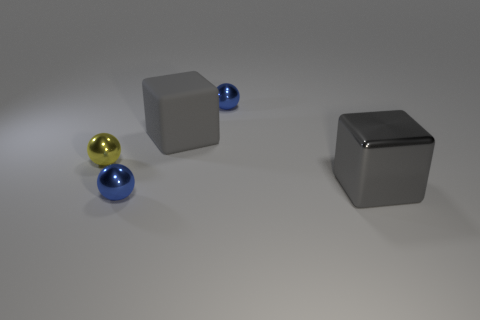Subtract all yellow shiny balls. How many balls are left? 2 Subtract all brown blocks. How many blue balls are left? 2 Add 4 rubber cubes. How many objects exist? 9 Subtract all balls. How many objects are left? 2 Subtract all green spheres. Subtract all purple blocks. How many spheres are left? 3 Add 1 small metal objects. How many small metal objects are left? 4 Add 5 yellow shiny things. How many yellow shiny things exist? 6 Subtract 1 yellow balls. How many objects are left? 4 Subtract all shiny balls. Subtract all tiny blue balls. How many objects are left? 0 